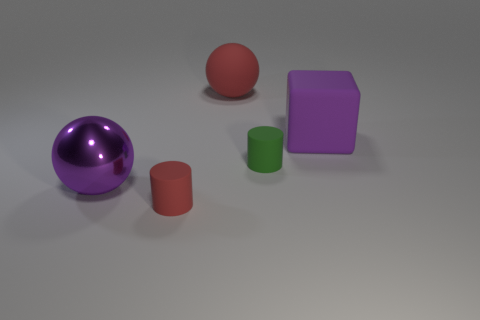What materials do the objects in the image look like they're made of? The objects in the image appear to be made of different materials. The sphere and the larger hemisphere look metallic due to their reflective surface, suggesting they could be made of polished metal. The red objects, both the ball and the cylinder, have a matte finish that could indicate rubber or plastic. The purple block's texture looks solid and less shiny, possibly resembling a matte plastic or some sort of painted wood. 